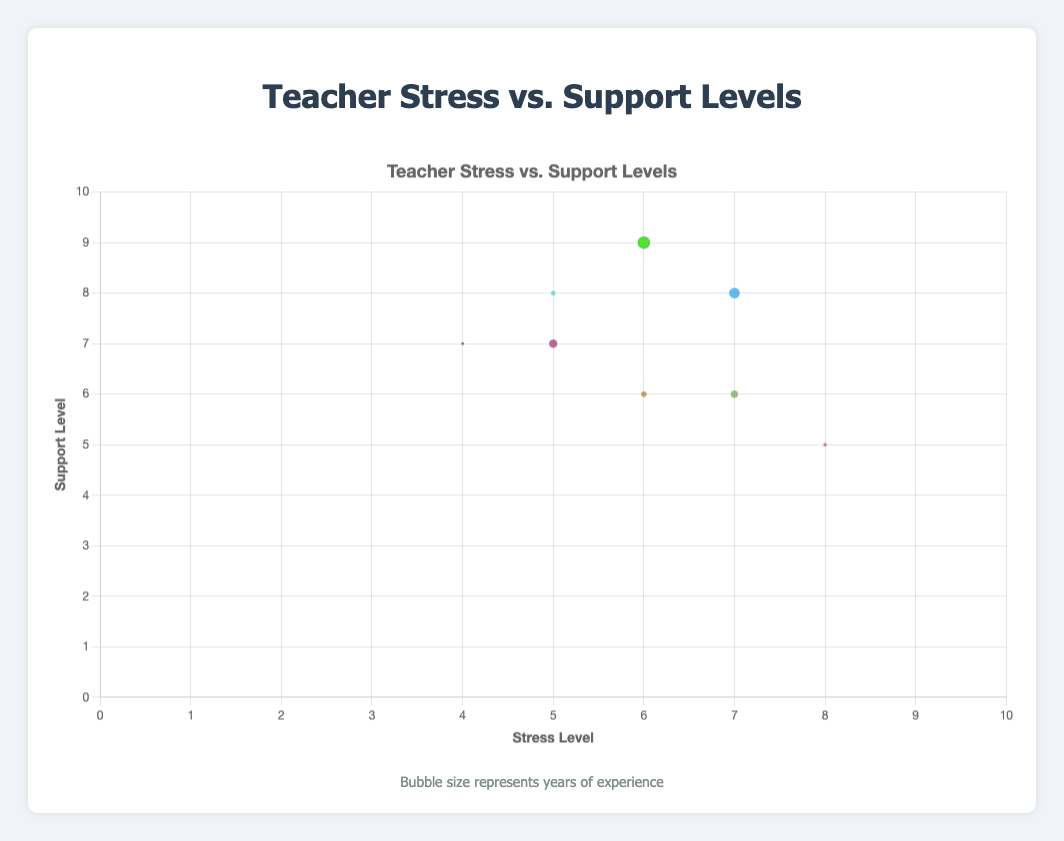What is the title of the chart? The title of the chart is generally found at the top center, and it describes the overall theme or subject of the chart. In this case, it reads "Teacher Stress vs. Support Levels".
Answer: Teacher Stress vs. Support Levels What does the size of the bubbles represent in the chart? In a bubble chart, the size of the bubbles typically represents a quantitative variable. According to the chart's legend, the bubble size represents the "Years of Experience" of the teachers.
Answer: Years of Experience How many teachers have a stress level of 7? To find this, check for bubbles with an x-coordinate of 7. By counting, we have Alice Johnson, Grace Lee, and Jackie Thompson, which makes three teachers.
Answer: 3 Which school has the teacher with the lowest stress level? Look for the bubble with the lowest x-value. The lowest stress level is 4, represented by Eva Hamilton at River Valley Elementary.
Answer: River Valley Elementary Which teacher has the highest support level and what is their stress level? Check for the bubble with the highest y-value. Derek Brown and Isabel Martin both have the highest support level of 9. Derek Brown's stress level is 6, and Isabel Martin's stress level is also 6.
Answer: Derek Brown, Isabel Martin; Stress Level: 6 What is the average support level of teachers with a stress level of 6? Identify the bubbles with an x-coordinate of 6: Brian Smith, Derek Brown, Isabel Martin. Their support levels are 6, 9, and 9 respectively. Calculate the average: (6 + 9 + 9) / 3 = 8.
Answer: 8 Which teacher has the most years of experience and what are their stress and support levels? Look for the largest bubble, representing the most years of experience. Derek Brown has the largest bubble with 12 years of experience. His stress level is 6, and his support level is 9.
Answer: Derek Brown; Stress Level: 6, Support Level: 9 Are there more teachers with a support level above 7 or below 7? Count the bubbles with y-coordinates above 7 and below 7. Above 7: Alice Johnson, Derek Brown, Henry Wilson, Isabel Martin (4); Below 7: Brian Smith, Cara Stevens, Grace Lee, Jackie Thompson (4).
Answer: Equal (4 each) Is there any teacher with a stress level of 5 and a support level of 7? Check for a bubble with x = 5 and y = 7. Frank Taylor's data point meets these criteria.
Answer: Yes, Frank Taylor How many teachers have a stress level greater than the support level? Compare x and y values for all bubbles. Cara Stevens (8 > 5) and Grace Lee (7 > 6), which makes two teachers.
Answer: 2 